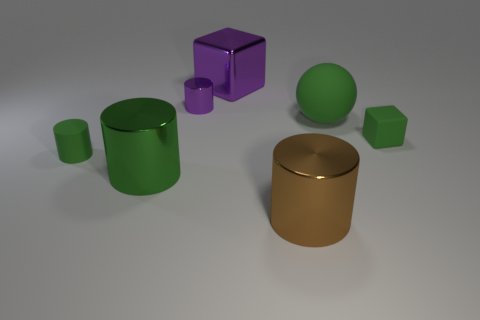How many blocks are either brown metal objects or small purple metal things? In the image, there are no brown metal objects or small purple metal things present. The objects visible are green and purple in color, and their sizes vary. The purple object is not small compared to the others, therefore the count of such specified objects is zero. 